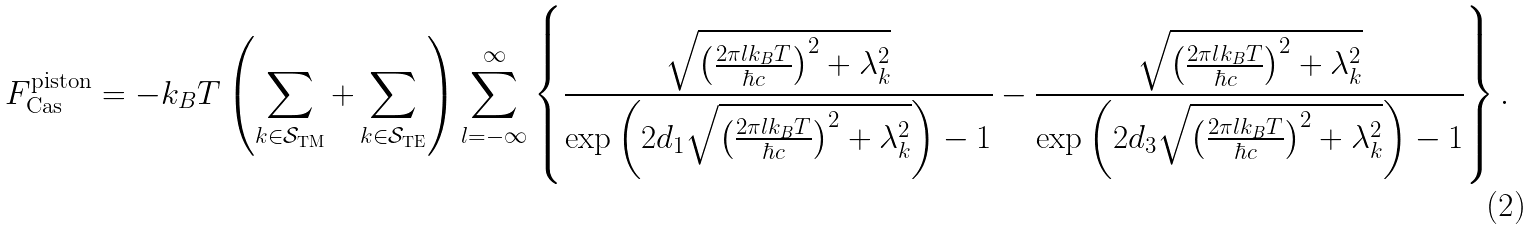<formula> <loc_0><loc_0><loc_500><loc_500>F _ { \text {Cas} } ^ { \text {piston} } = - k _ { B } T \left ( \sum _ { k \in \mathcal { S } _ { \text {TM} } } + \sum _ { k \in \mathcal { S } _ { \text {TE} } } \right ) \sum _ { l = - \infty } ^ { \infty } \left \{ \frac { \sqrt { \left ( \frac { 2 \pi l k _ { B } T } { \hbar { c } } \right ) ^ { 2 } + \lambda _ { k } ^ { 2 } } } { \exp \left ( 2 d _ { 1 } \sqrt { \left ( \frac { 2 \pi l k _ { B } T } { \hbar { c } } \right ) ^ { 2 } + \lambda _ { k } ^ { 2 } } \right ) - 1 } - \frac { \sqrt { \left ( \frac { 2 \pi l k _ { B } T } { \hbar { c } } \right ) ^ { 2 } + \lambda _ { k } ^ { 2 } } } { \exp \left ( 2 d _ { 3 } \sqrt { \left ( \frac { 2 \pi l k _ { B } T } { \hbar { c } } \right ) ^ { 2 } + \lambda _ { k } ^ { 2 } } \right ) - 1 } \right \} .</formula> 